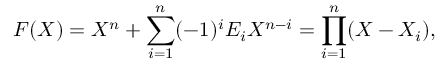Convert formula to latex. <formula><loc_0><loc_0><loc_500><loc_500>F ( X ) = X ^ { n } + \sum _ { i = 1 } ^ { n } ( - 1 ) ^ { i } E _ { i } X ^ { n - i } = \prod _ { i = 1 } ^ { n } ( X - X _ { i } ) ,</formula> 